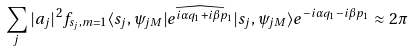Convert formula to latex. <formula><loc_0><loc_0><loc_500><loc_500>\sum _ { j } | a _ { j } | ^ { 2 } f _ { s _ { j } , m = 1 } \langle s _ { j } , \psi _ { j M } | \widehat { e ^ { i \alpha q _ { 1 } + i \beta p _ { 1 } } } | s _ { j } , \psi _ { j M } \rangle e ^ { - i \alpha q _ { 1 } - i \beta p _ { 1 } } \approx 2 \pi</formula> 